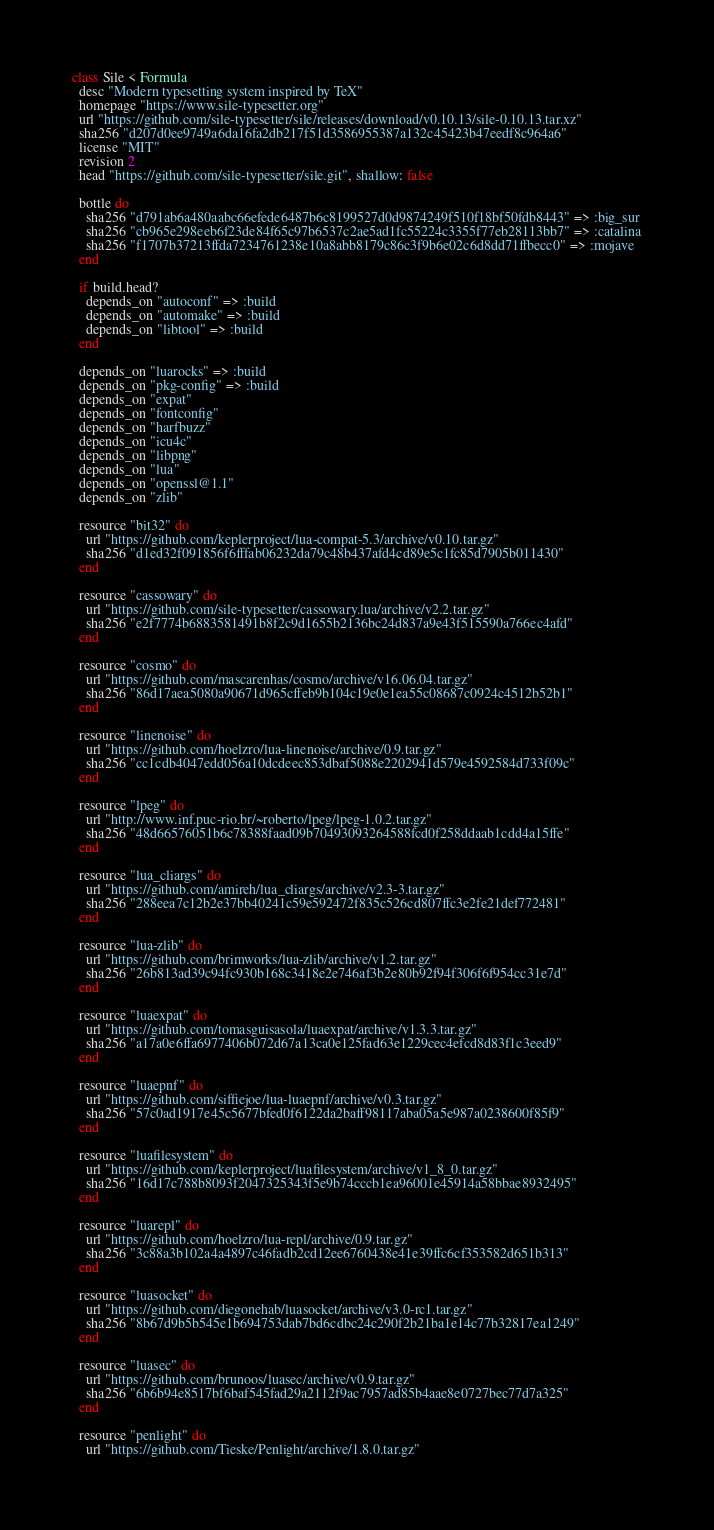Convert code to text. <code><loc_0><loc_0><loc_500><loc_500><_Ruby_>class Sile < Formula
  desc "Modern typesetting system inspired by TeX"
  homepage "https://www.sile-typesetter.org"
  url "https://github.com/sile-typesetter/sile/releases/download/v0.10.13/sile-0.10.13.tar.xz"
  sha256 "d207d0ee9749a6da16fa2db217f51d3586955387a132c45423b47eedf8c964a6"
  license "MIT"
  revision 2
  head "https://github.com/sile-typesetter/sile.git", shallow: false

  bottle do
    sha256 "d791ab6a480aabc66efede6487b6c8199527d0d9874249f510f18bf50fdb8443" => :big_sur
    sha256 "cb965e298eeb6f23de84f65c97b6537c2ae5ad1fc55224c3355f77eb28113bb7" => :catalina
    sha256 "f1707b37213ffda7234761238e10a8abb8179c86c3f9b6e02c6d8dd71ffbecc0" => :mojave
  end

  if build.head?
    depends_on "autoconf" => :build
    depends_on "automake" => :build
    depends_on "libtool" => :build
  end

  depends_on "luarocks" => :build
  depends_on "pkg-config" => :build
  depends_on "expat"
  depends_on "fontconfig"
  depends_on "harfbuzz"
  depends_on "icu4c"
  depends_on "libpng"
  depends_on "lua"
  depends_on "openssl@1.1"
  depends_on "zlib"

  resource "bit32" do
    url "https://github.com/keplerproject/lua-compat-5.3/archive/v0.10.tar.gz"
    sha256 "d1ed32f091856f6fffab06232da79c48b437afd4cd89e5c1fc85d7905b011430"
  end

  resource "cassowary" do
    url "https://github.com/sile-typesetter/cassowary.lua/archive/v2.2.tar.gz"
    sha256 "e2f7774b6883581491b8f2c9d1655b2136bc24d837a9e43f515590a766ec4afd"
  end

  resource "cosmo" do
    url "https://github.com/mascarenhas/cosmo/archive/v16.06.04.tar.gz"
    sha256 "86d17aea5080a90671d965cffeb9b104c19e0e1ea55c08687c0924c4512b52b1"
  end

  resource "linenoise" do
    url "https://github.com/hoelzro/lua-linenoise/archive/0.9.tar.gz"
    sha256 "cc1cdb4047edd056a10dcdeec853dbaf5088e2202941d579e4592584d733f09c"
  end

  resource "lpeg" do
    url "http://www.inf.puc-rio.br/~roberto/lpeg/lpeg-1.0.2.tar.gz"
    sha256 "48d66576051b6c78388faad09b70493093264588fcd0f258ddaab1cdd4a15ffe"
  end

  resource "lua_cliargs" do
    url "https://github.com/amireh/lua_cliargs/archive/v2.3-3.tar.gz"
    sha256 "288eea7c12b2e37bb40241c59e592472f835c526cd807ffc3e2fe21def772481"
  end

  resource "lua-zlib" do
    url "https://github.com/brimworks/lua-zlib/archive/v1.2.tar.gz"
    sha256 "26b813ad39c94fc930b168c3418e2e746af3b2e80b92f94f306f6f954cc31e7d"
  end

  resource "luaexpat" do
    url "https://github.com/tomasguisasola/luaexpat/archive/v1.3.3.tar.gz"
    sha256 "a17a0e6ffa6977406b072d67a13ca0e125fad63e1229cec4efcd8d83f1c3eed9"
  end

  resource "luaepnf" do
    url "https://github.com/siffiejoe/lua-luaepnf/archive/v0.3.tar.gz"
    sha256 "57c0ad1917e45c5677bfed0f6122da2baff98117aba05a5e987a0238600f85f9"
  end

  resource "luafilesystem" do
    url "https://github.com/keplerproject/luafilesystem/archive/v1_8_0.tar.gz"
    sha256 "16d17c788b8093f2047325343f5e9b74cccb1ea96001e45914a58bbae8932495"
  end

  resource "luarepl" do
    url "https://github.com/hoelzro/lua-repl/archive/0.9.tar.gz"
    sha256 "3c88a3b102a4a4897c46fadb2cd12ee6760438e41e39ffc6cf353582d651b313"
  end

  resource "luasocket" do
    url "https://github.com/diegonehab/luasocket/archive/v3.0-rc1.tar.gz"
    sha256 "8b67d9b5b545e1b694753dab7bd6cdbc24c290f2b21ba1e14c77b32817ea1249"
  end

  resource "luasec" do
    url "https://github.com/brunoos/luasec/archive/v0.9.tar.gz"
    sha256 "6b6b94e8517bf6baf545fad29a2112f9ac7957ad85b4aae8e0727bec77d7a325"
  end

  resource "penlight" do
    url "https://github.com/Tieske/Penlight/archive/1.8.0.tar.gz"</code> 